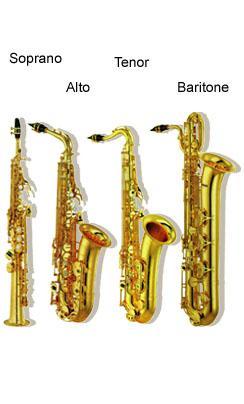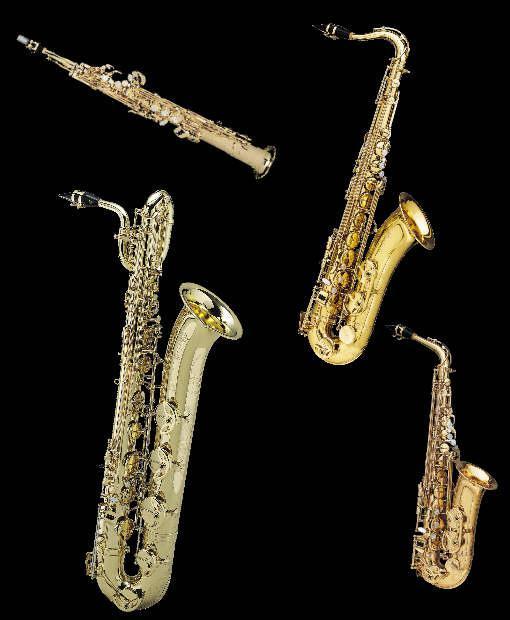The first image is the image on the left, the second image is the image on the right. For the images displayed, is the sentence "Right and left images each show four instruments, including one that is straight and three with curved mouthpieces and bell ends." factually correct? Answer yes or no. Yes. The first image is the image on the left, the second image is the image on the right. For the images shown, is this caption "Four instruments are lined up together in the image on the left." true? Answer yes or no. Yes. 